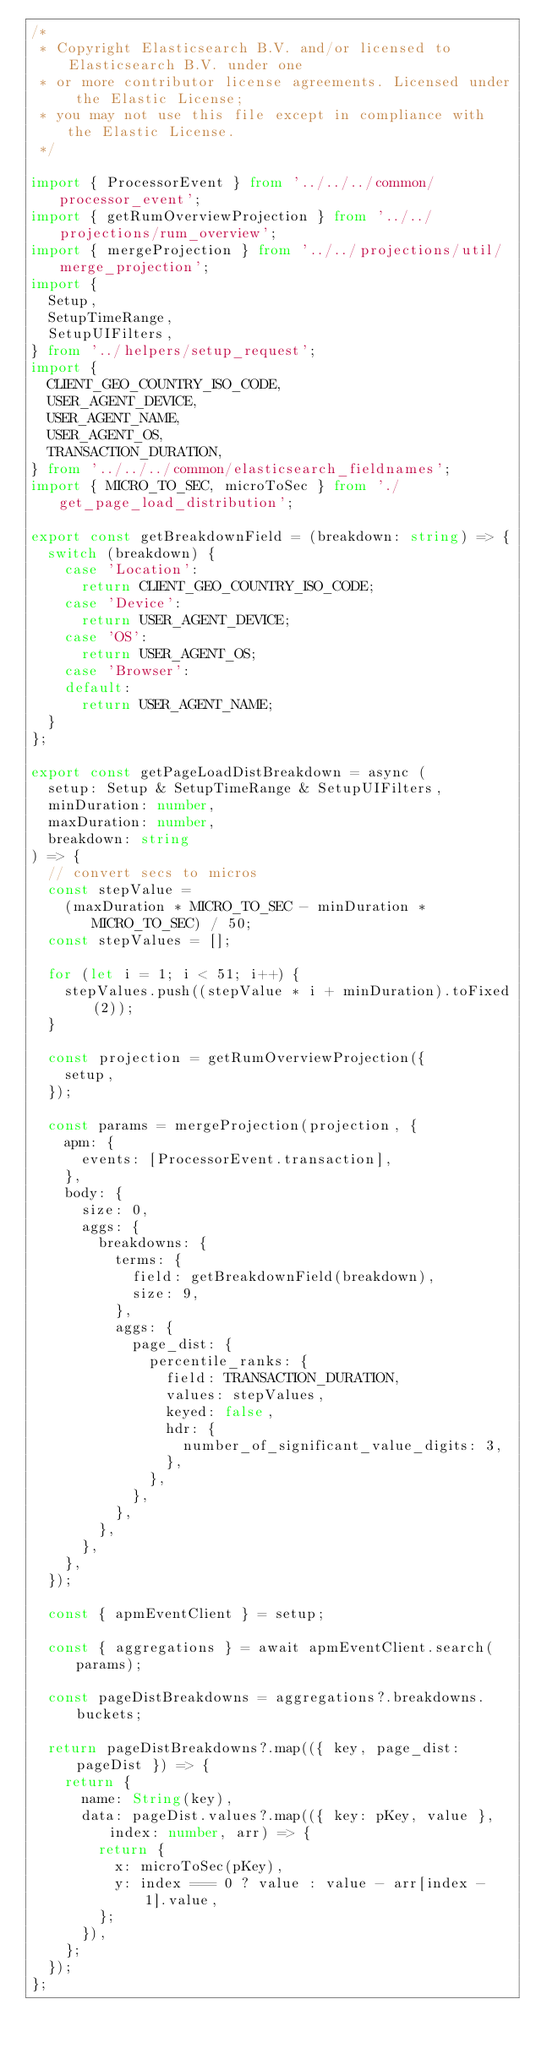Convert code to text. <code><loc_0><loc_0><loc_500><loc_500><_TypeScript_>/*
 * Copyright Elasticsearch B.V. and/or licensed to Elasticsearch B.V. under one
 * or more contributor license agreements. Licensed under the Elastic License;
 * you may not use this file except in compliance with the Elastic License.
 */

import { ProcessorEvent } from '../../../common/processor_event';
import { getRumOverviewProjection } from '../../projections/rum_overview';
import { mergeProjection } from '../../projections/util/merge_projection';
import {
  Setup,
  SetupTimeRange,
  SetupUIFilters,
} from '../helpers/setup_request';
import {
  CLIENT_GEO_COUNTRY_ISO_CODE,
  USER_AGENT_DEVICE,
  USER_AGENT_NAME,
  USER_AGENT_OS,
  TRANSACTION_DURATION,
} from '../../../common/elasticsearch_fieldnames';
import { MICRO_TO_SEC, microToSec } from './get_page_load_distribution';

export const getBreakdownField = (breakdown: string) => {
  switch (breakdown) {
    case 'Location':
      return CLIENT_GEO_COUNTRY_ISO_CODE;
    case 'Device':
      return USER_AGENT_DEVICE;
    case 'OS':
      return USER_AGENT_OS;
    case 'Browser':
    default:
      return USER_AGENT_NAME;
  }
};

export const getPageLoadDistBreakdown = async (
  setup: Setup & SetupTimeRange & SetupUIFilters,
  minDuration: number,
  maxDuration: number,
  breakdown: string
) => {
  // convert secs to micros
  const stepValue =
    (maxDuration * MICRO_TO_SEC - minDuration * MICRO_TO_SEC) / 50;
  const stepValues = [];

  for (let i = 1; i < 51; i++) {
    stepValues.push((stepValue * i + minDuration).toFixed(2));
  }

  const projection = getRumOverviewProjection({
    setup,
  });

  const params = mergeProjection(projection, {
    apm: {
      events: [ProcessorEvent.transaction],
    },
    body: {
      size: 0,
      aggs: {
        breakdowns: {
          terms: {
            field: getBreakdownField(breakdown),
            size: 9,
          },
          aggs: {
            page_dist: {
              percentile_ranks: {
                field: TRANSACTION_DURATION,
                values: stepValues,
                keyed: false,
                hdr: {
                  number_of_significant_value_digits: 3,
                },
              },
            },
          },
        },
      },
    },
  });

  const { apmEventClient } = setup;

  const { aggregations } = await apmEventClient.search(params);

  const pageDistBreakdowns = aggregations?.breakdowns.buckets;

  return pageDistBreakdowns?.map(({ key, page_dist: pageDist }) => {
    return {
      name: String(key),
      data: pageDist.values?.map(({ key: pKey, value }, index: number, arr) => {
        return {
          x: microToSec(pKey),
          y: index === 0 ? value : value - arr[index - 1].value,
        };
      }),
    };
  });
};
</code> 